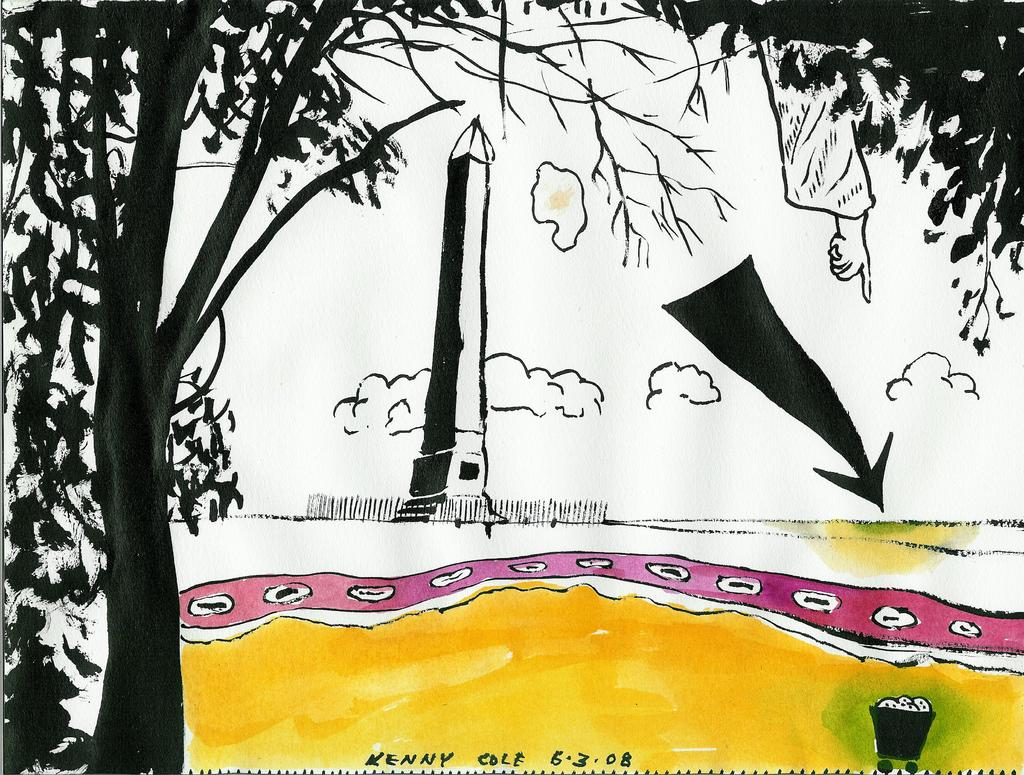What is the main subject of the painting in the image? The painting depicts clouds, a human hand, trees, a tower, and a trash trolley. Can you describe the landscape depicted in the painting? The painting depicts clouds, trees, and a tower, suggesting a landscape with natural elements and a man-made structure. What other object is present in the painting? The painting also depicts a trash trolley. How many sisters are depicted in the painting? There are no sisters depicted in the painting; it features clouds, a human hand, trees, a tower, and a trash trolley. What type of feast is being held in the painting? There is no feast depicted in the painting; it features clouds, a human hand, trees, a tower, and a trash trolley. 